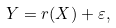<formula> <loc_0><loc_0><loc_500><loc_500>Y = r ( X ) + \varepsilon ,</formula> 